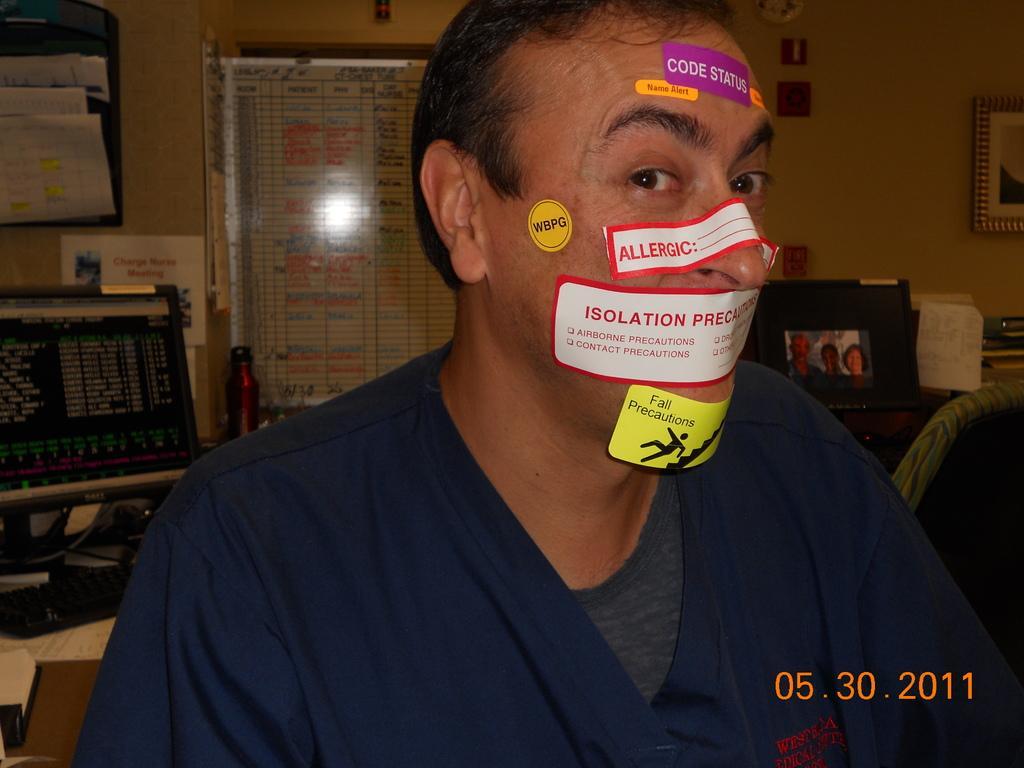In one or two sentences, can you explain what this image depicts? In the foreground I can see a man and stickers on his face. In the background I can see a chair, tables on which I can see systems and books. At the top I can see a wall, photo frame, board and some objects. This image is taken may be in a room. 